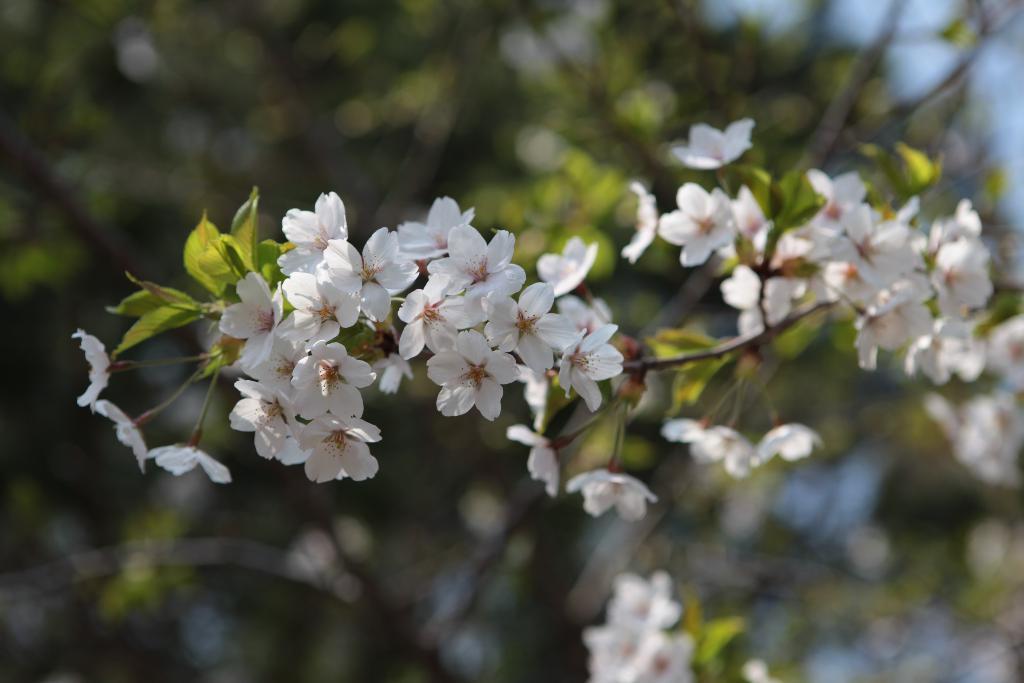How would you summarize this image in a sentence or two? In this image we can see a group of flowers and a tree. The background of the image is blurred. 